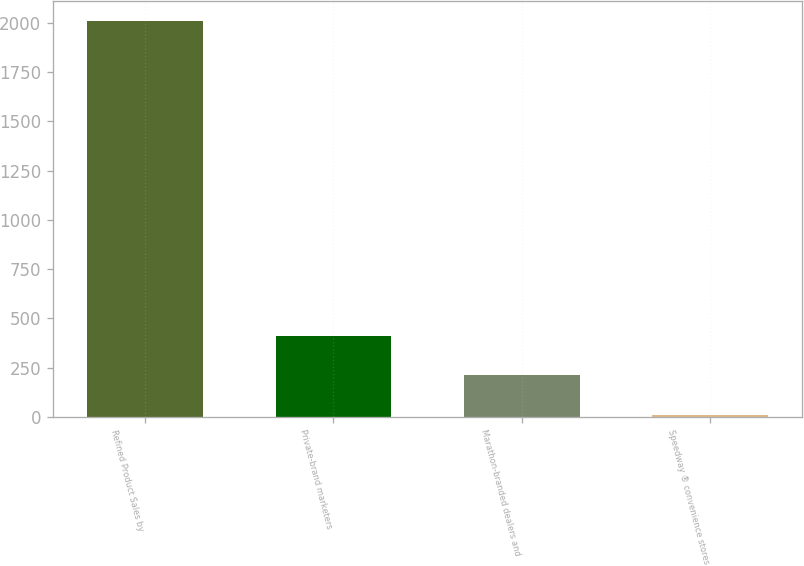Convert chart to OTSL. <chart><loc_0><loc_0><loc_500><loc_500><bar_chart><fcel>Refined Product Sales by<fcel>Private-brand marketers<fcel>Marathon-branded dealers and<fcel>Speedway ® convenience stores<nl><fcel>2012<fcel>411.2<fcel>211.1<fcel>11<nl></chart> 